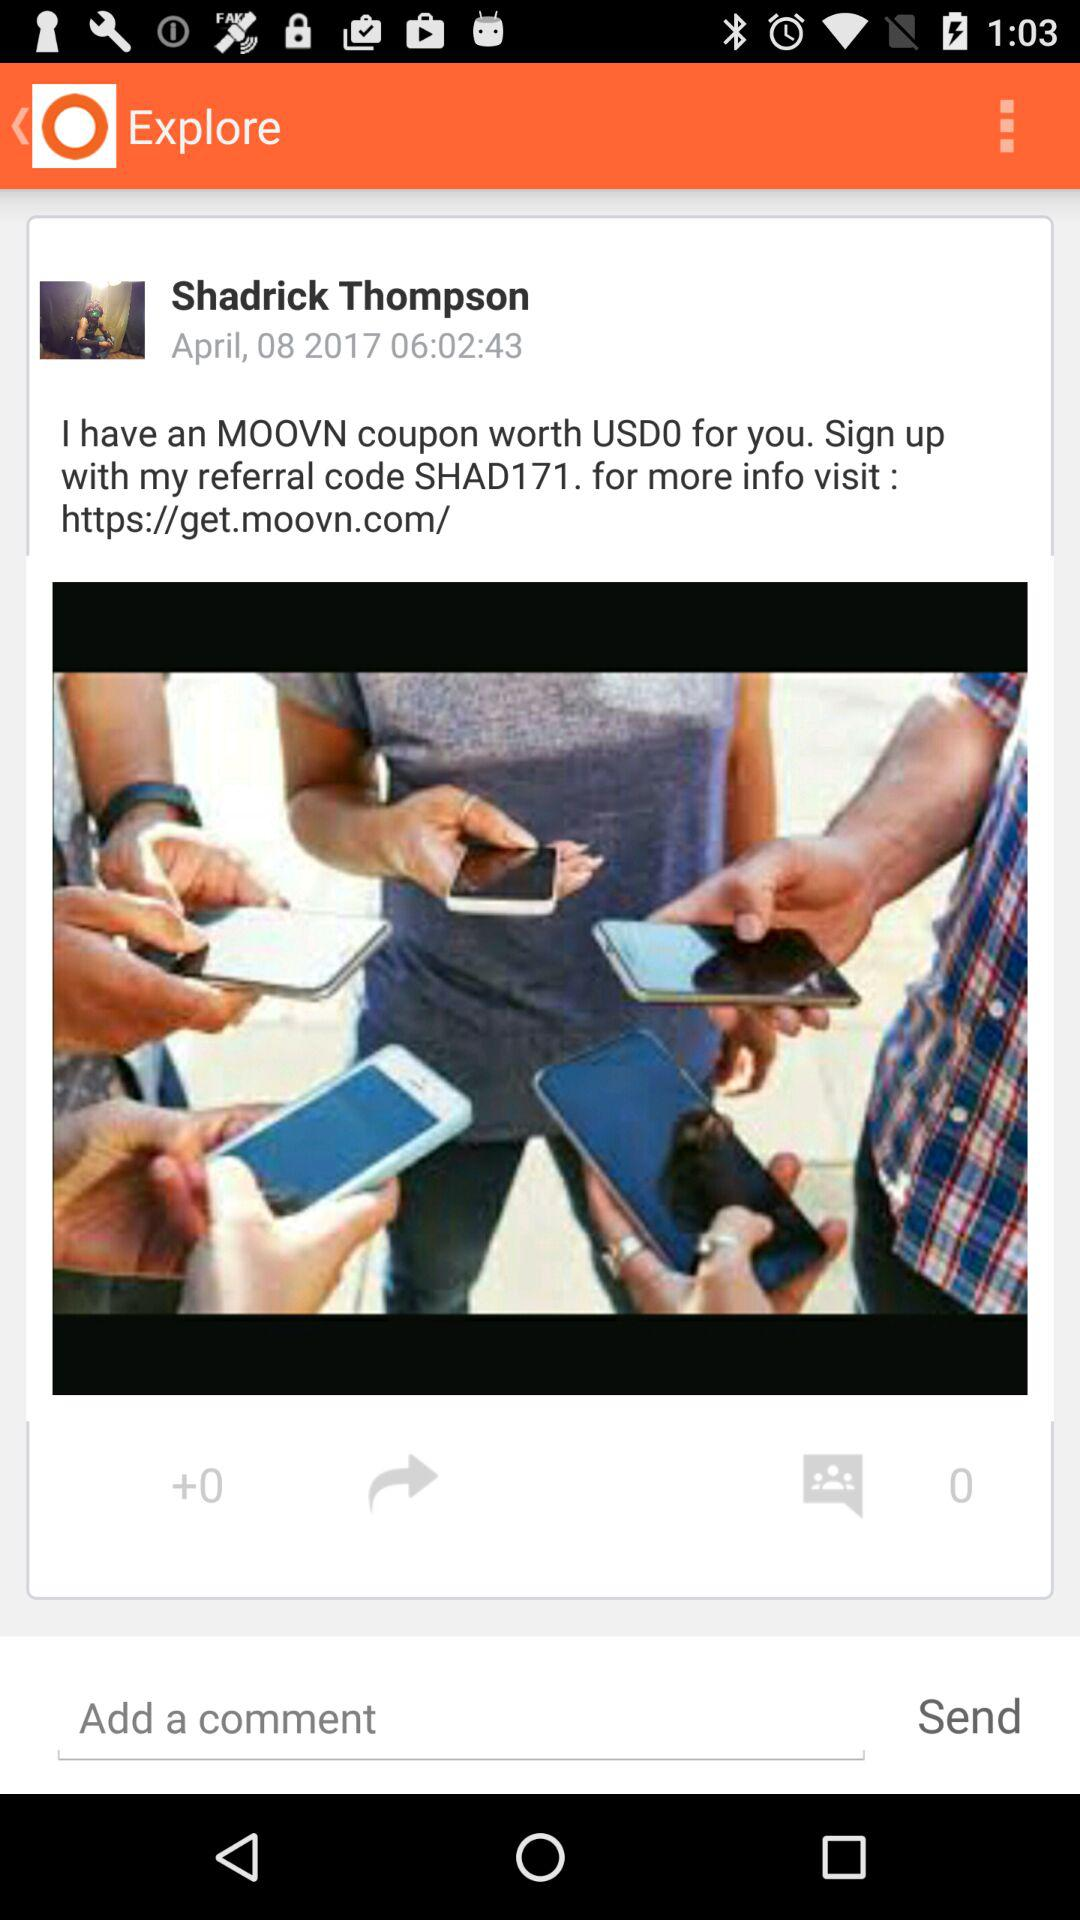What is the hyperlink? The hyperlink is https://get.moovn.com/. 